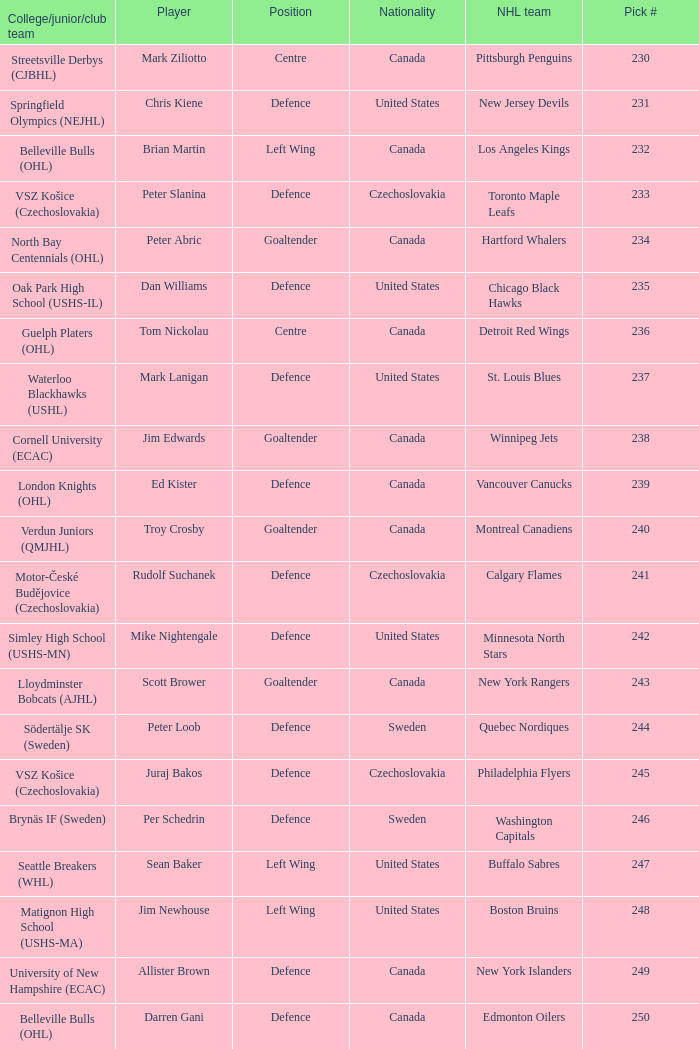To which organziation does the  winnipeg jets belong to? Cornell University (ECAC). 